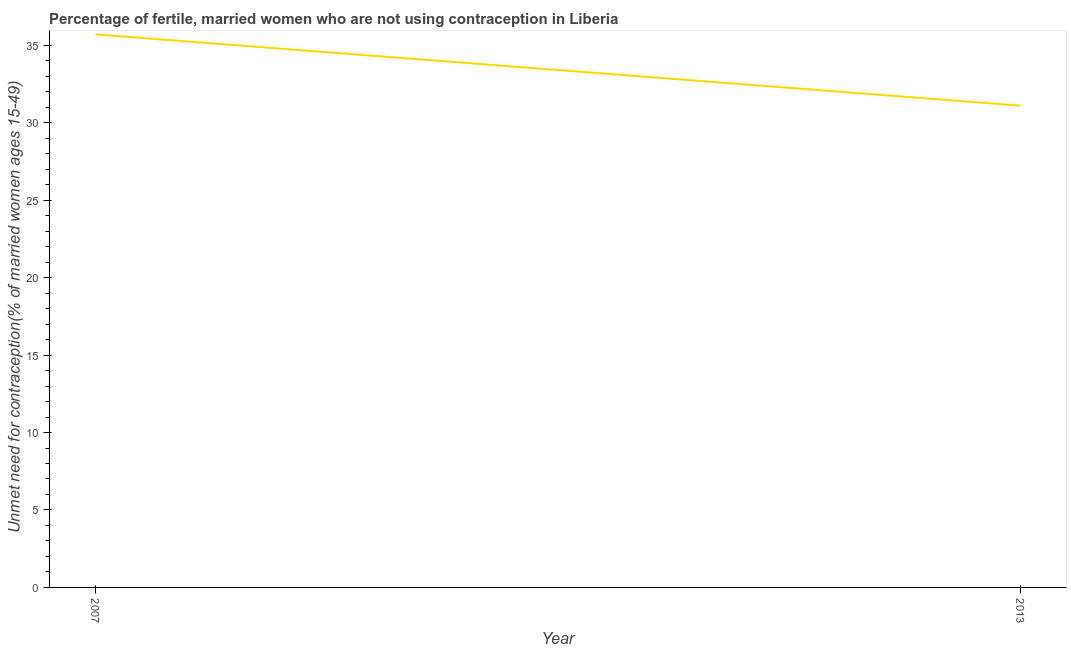What is the number of married women who are not using contraception in 2007?
Your answer should be compact. 35.7. Across all years, what is the maximum number of married women who are not using contraception?
Provide a short and direct response. 35.7. Across all years, what is the minimum number of married women who are not using contraception?
Provide a succinct answer. 31.1. What is the sum of the number of married women who are not using contraception?
Ensure brevity in your answer.  66.8. What is the difference between the number of married women who are not using contraception in 2007 and 2013?
Provide a short and direct response. 4.6. What is the average number of married women who are not using contraception per year?
Provide a short and direct response. 33.4. What is the median number of married women who are not using contraception?
Offer a very short reply. 33.4. Do a majority of the years between 2013 and 2007 (inclusive) have number of married women who are not using contraception greater than 10 %?
Keep it short and to the point. No. What is the ratio of the number of married women who are not using contraception in 2007 to that in 2013?
Your answer should be very brief. 1.15. In how many years, is the number of married women who are not using contraception greater than the average number of married women who are not using contraception taken over all years?
Your answer should be compact. 1. Does the number of married women who are not using contraception monotonically increase over the years?
Your answer should be very brief. No. How many years are there in the graph?
Your response must be concise. 2. What is the difference between two consecutive major ticks on the Y-axis?
Give a very brief answer. 5. Are the values on the major ticks of Y-axis written in scientific E-notation?
Offer a very short reply. No. What is the title of the graph?
Keep it short and to the point. Percentage of fertile, married women who are not using contraception in Liberia. What is the label or title of the X-axis?
Provide a succinct answer. Year. What is the label or title of the Y-axis?
Ensure brevity in your answer.   Unmet need for contraception(% of married women ages 15-49). What is the  Unmet need for contraception(% of married women ages 15-49) of 2007?
Ensure brevity in your answer.  35.7. What is the  Unmet need for contraception(% of married women ages 15-49) of 2013?
Keep it short and to the point. 31.1. What is the ratio of the  Unmet need for contraception(% of married women ages 15-49) in 2007 to that in 2013?
Provide a succinct answer. 1.15. 